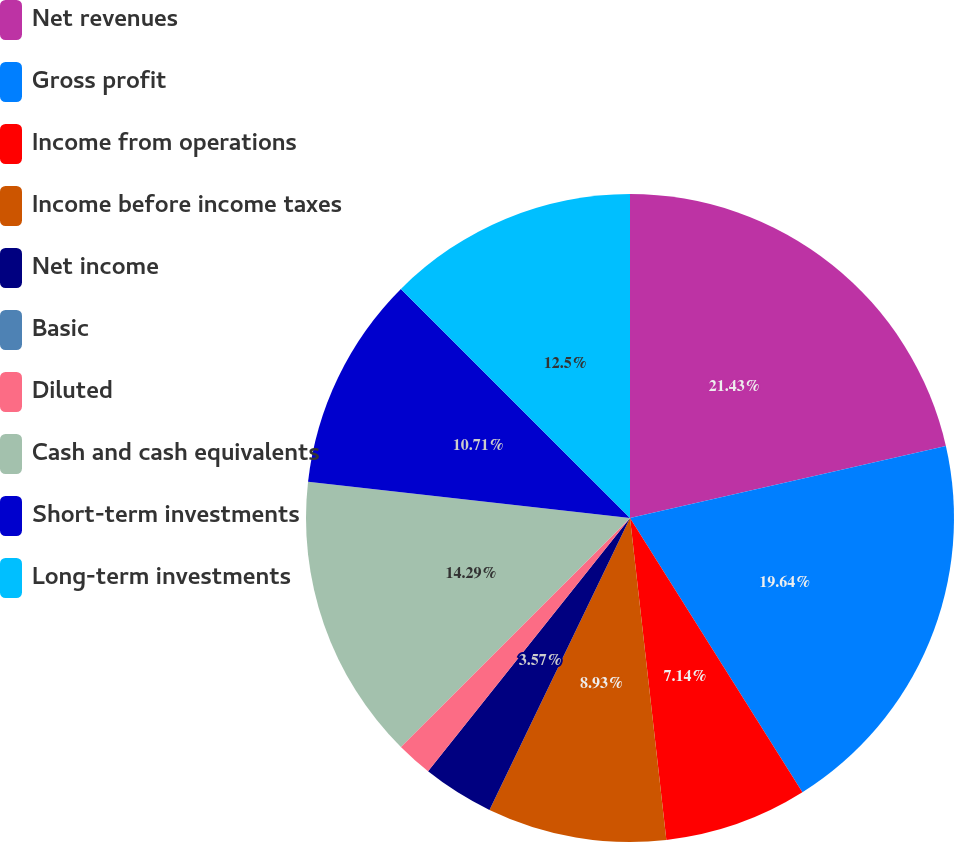Convert chart. <chart><loc_0><loc_0><loc_500><loc_500><pie_chart><fcel>Net revenues<fcel>Gross profit<fcel>Income from operations<fcel>Income before income taxes<fcel>Net income<fcel>Basic<fcel>Diluted<fcel>Cash and cash equivalents<fcel>Short-term investments<fcel>Long-term investments<nl><fcel>21.43%<fcel>19.64%<fcel>7.14%<fcel>8.93%<fcel>3.57%<fcel>0.0%<fcel>1.79%<fcel>14.29%<fcel>10.71%<fcel>12.5%<nl></chart> 